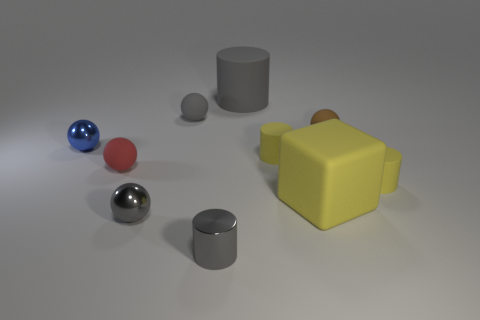Subtract 2 balls. How many balls are left? 3 Subtract all brown balls. How many balls are left? 4 Subtract all tiny gray metallic balls. How many balls are left? 4 Subtract all green balls. Subtract all brown cylinders. How many balls are left? 5 Subtract all cubes. How many objects are left? 9 Add 7 matte spheres. How many matte spheres exist? 10 Subtract 1 red balls. How many objects are left? 9 Subtract all metal cylinders. Subtract all yellow rubber blocks. How many objects are left? 8 Add 7 tiny gray shiny balls. How many tiny gray shiny balls are left? 8 